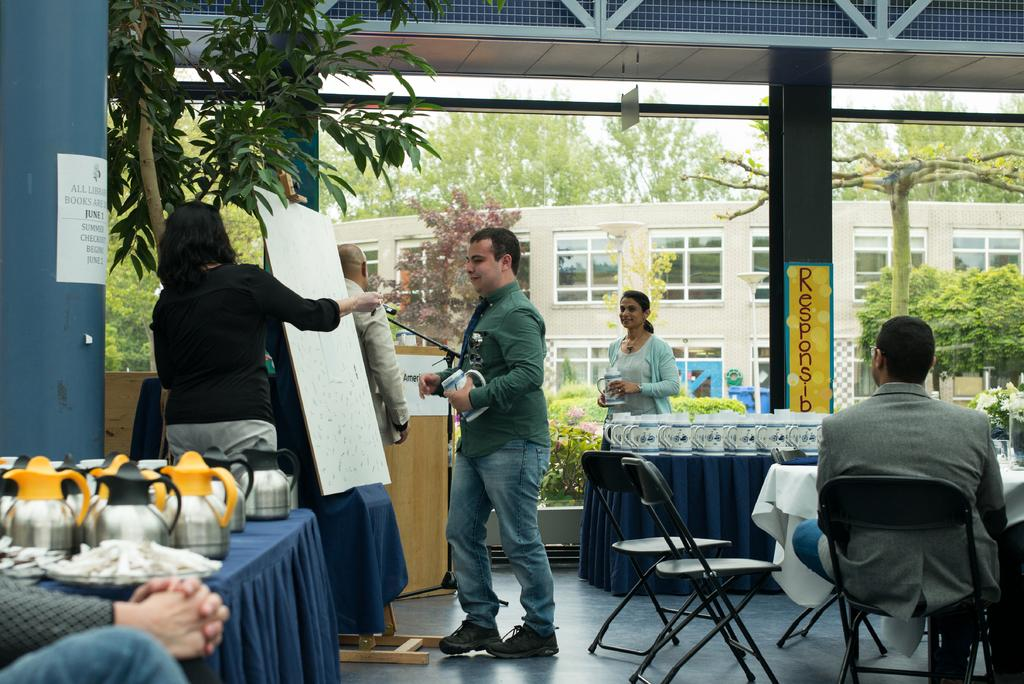What type of natural elements can be seen in the image? There are trees in the image. What type of man-made structure is present in the image? There is a building in the image. Are there any people in the image? Yes, there are people in the image. What object can be seen in the image that might be used for displaying information or messages? There is a board in the image. What type of furniture is present in the image? There are chairs and tables in the image. What items can be seen on the table in the image? There are cups on the table. Can you tell me how many boats are visible in the image? There are no boats present in the image. What is the mass of the cups on the table? The mass of the cups cannot be determined from the image alone, as it does not provide information about their weight or size. 